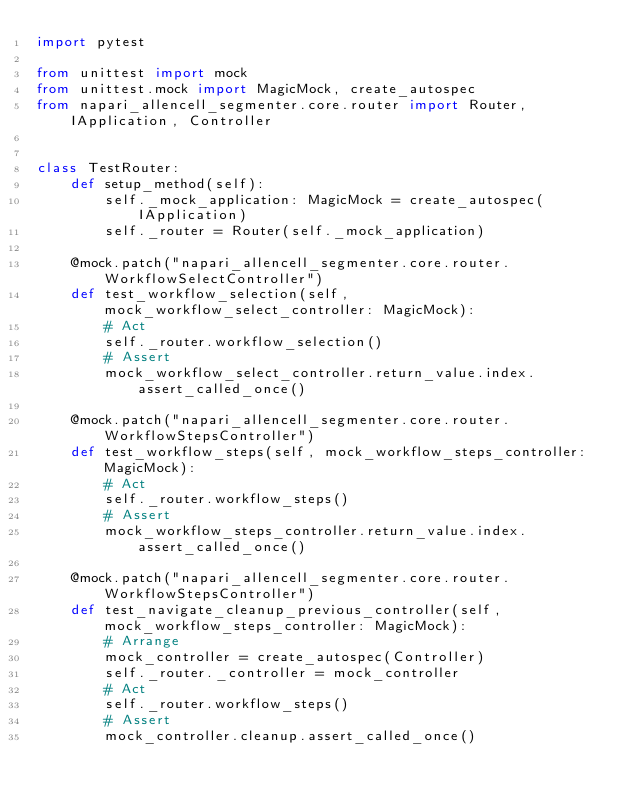<code> <loc_0><loc_0><loc_500><loc_500><_Python_>import pytest

from unittest import mock
from unittest.mock import MagicMock, create_autospec
from napari_allencell_segmenter.core.router import Router, IApplication, Controller


class TestRouter:
    def setup_method(self):
        self._mock_application: MagicMock = create_autospec(IApplication)
        self._router = Router(self._mock_application)

    @mock.patch("napari_allencell_segmenter.core.router.WorkflowSelectController")
    def test_workflow_selection(self, mock_workflow_select_controller: MagicMock):
        # Act
        self._router.workflow_selection()
        # Assert
        mock_workflow_select_controller.return_value.index.assert_called_once()

    @mock.patch("napari_allencell_segmenter.core.router.WorkflowStepsController")
    def test_workflow_steps(self, mock_workflow_steps_controller: MagicMock):
        # Act
        self._router.workflow_steps()
        # Assert
        mock_workflow_steps_controller.return_value.index.assert_called_once()

    @mock.patch("napari_allencell_segmenter.core.router.WorkflowStepsController")
    def test_navigate_cleanup_previous_controller(self, mock_workflow_steps_controller: MagicMock):
        # Arrange
        mock_controller = create_autospec(Controller)
        self._router._controller = mock_controller
        # Act
        self._router.workflow_steps()
        # Assert
        mock_controller.cleanup.assert_called_once()
</code> 